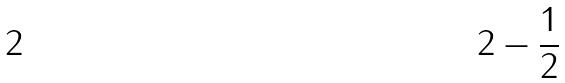<formula> <loc_0><loc_0><loc_500><loc_500>2 - \frac { 1 } { 2 }</formula> 